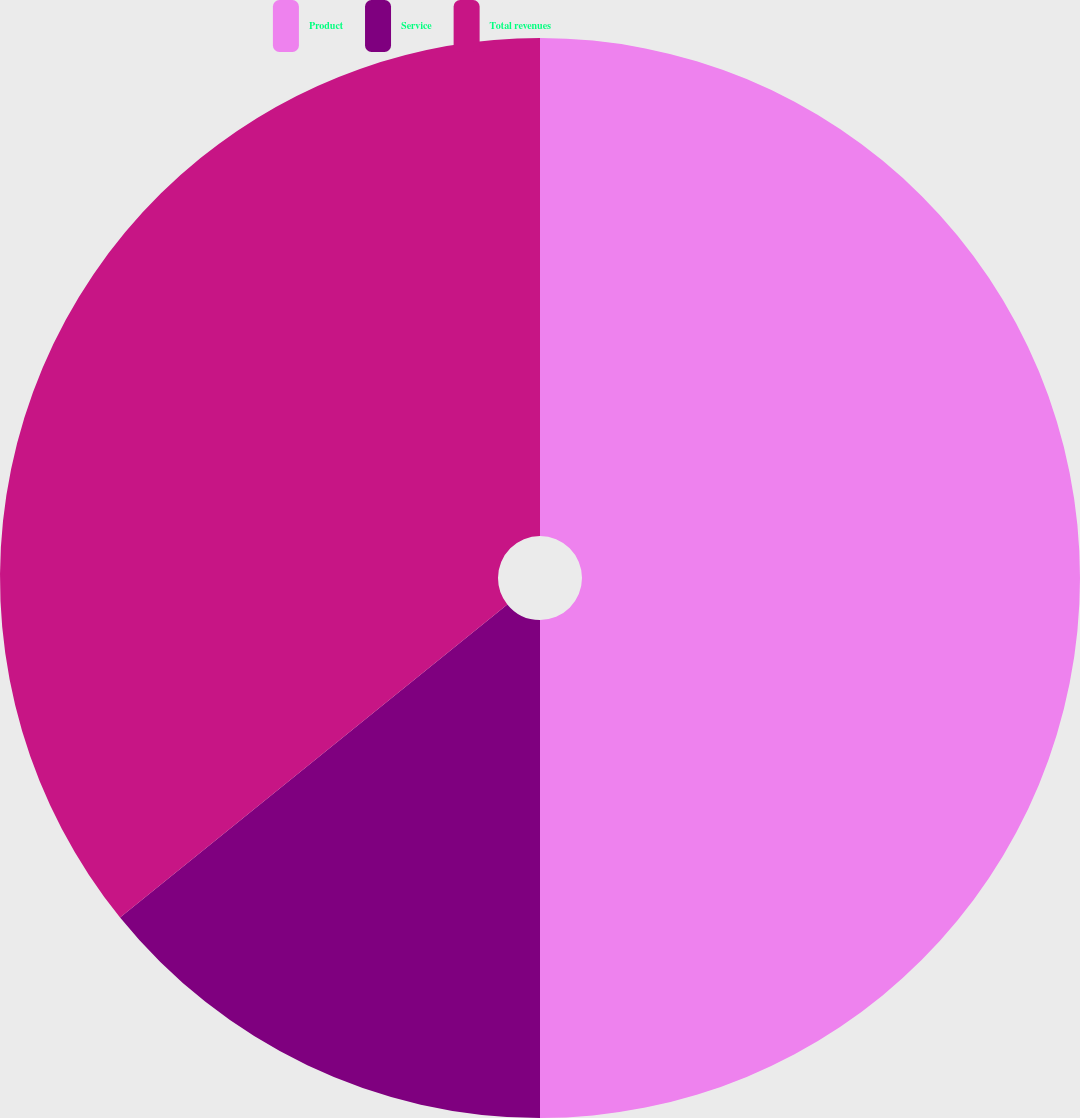Convert chart to OTSL. <chart><loc_0><loc_0><loc_500><loc_500><pie_chart><fcel>Product<fcel>Service<fcel>Total revenues<nl><fcel>50.0%<fcel>14.18%<fcel>35.82%<nl></chart> 